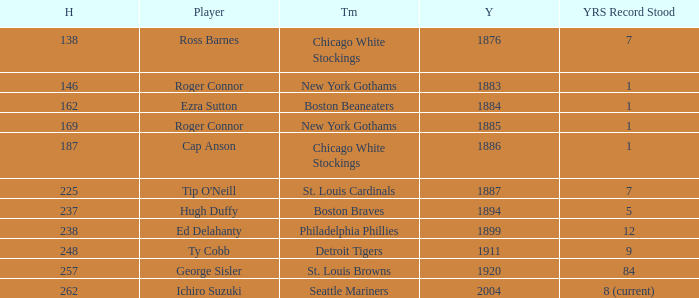Name the least hits for year less than 1920 and player of ed delahanty 238.0. 